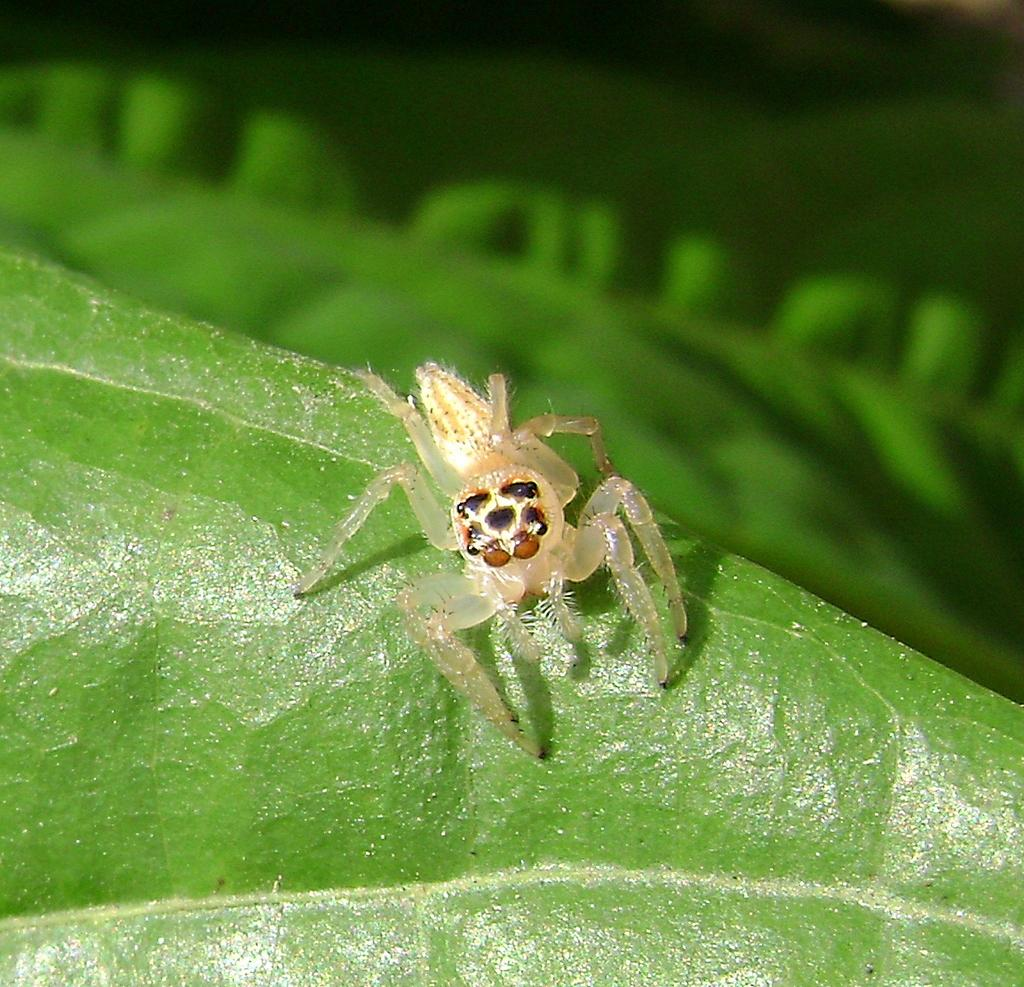What type of creature can be seen in the image? There is an insect in the image. What is the insect resting on in the image? The insect is on a green surface. Can you describe the background of the image? The background of the image is blurred. How does the insect join the other insects in the image? There are no other insects present in the image for the insect to join. 